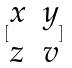<formula> <loc_0><loc_0><loc_500><loc_500>[ \begin{matrix} x & y \\ z & v \end{matrix} ]</formula> 